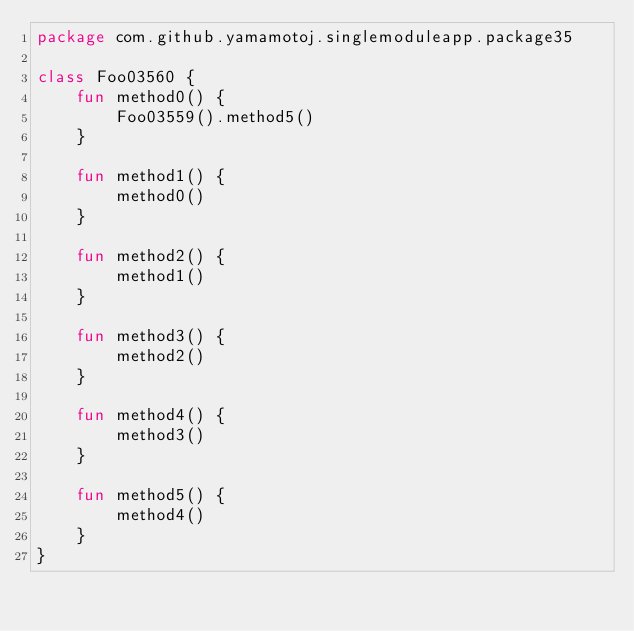<code> <loc_0><loc_0><loc_500><loc_500><_Kotlin_>package com.github.yamamotoj.singlemoduleapp.package35

class Foo03560 {
    fun method0() {
        Foo03559().method5()
    }

    fun method1() {
        method0()
    }

    fun method2() {
        method1()
    }

    fun method3() {
        method2()
    }

    fun method4() {
        method3()
    }

    fun method5() {
        method4()
    }
}
</code> 